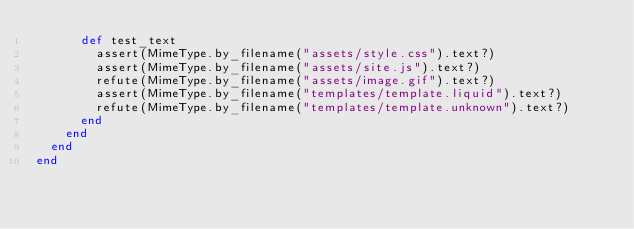<code> <loc_0><loc_0><loc_500><loc_500><_Ruby_>      def test_text
        assert(MimeType.by_filename("assets/style.css").text?)
        assert(MimeType.by_filename("assets/site.js").text?)
        refute(MimeType.by_filename("assets/image.gif").text?)
        assert(MimeType.by_filename("templates/template.liquid").text?)
        refute(MimeType.by_filename("templates/template.unknown").text?)
      end
    end
  end
end
</code> 